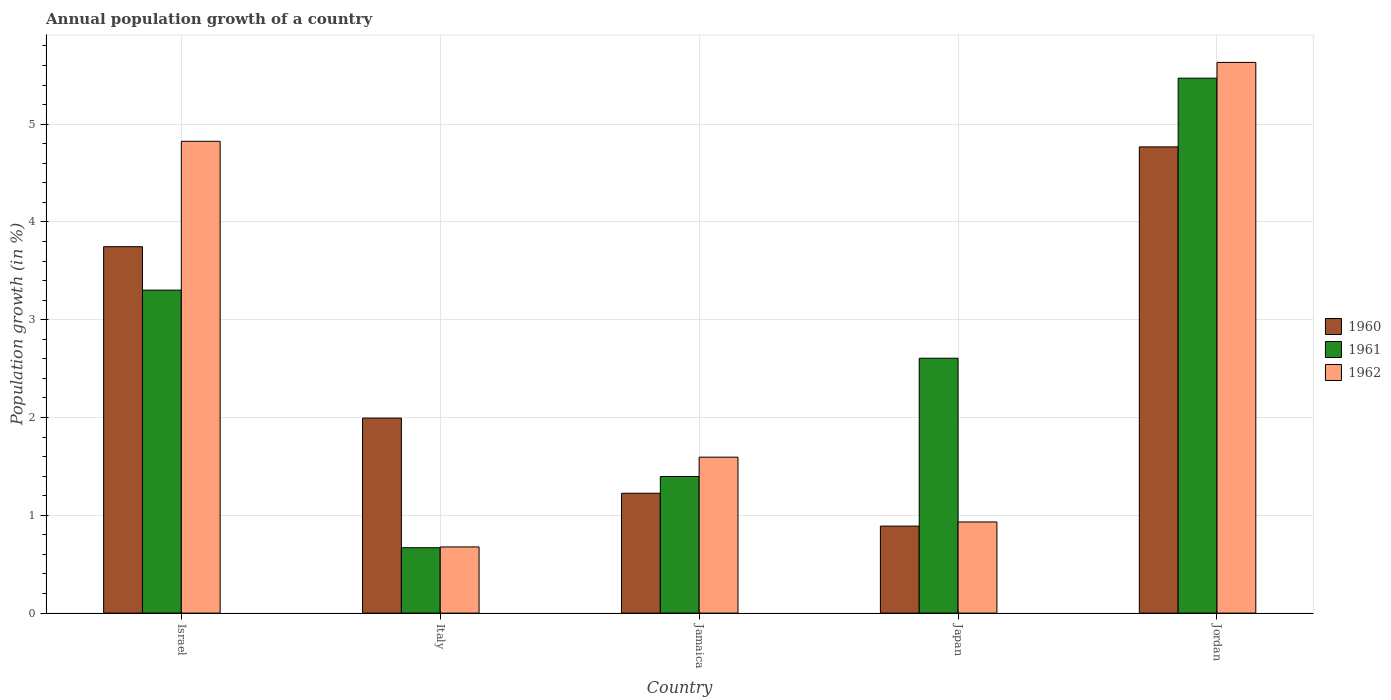How many different coloured bars are there?
Provide a short and direct response. 3. Are the number of bars on each tick of the X-axis equal?
Keep it short and to the point. Yes. How many bars are there on the 3rd tick from the right?
Offer a very short reply. 3. What is the label of the 1st group of bars from the left?
Provide a short and direct response. Israel. In how many cases, is the number of bars for a given country not equal to the number of legend labels?
Your answer should be very brief. 0. What is the annual population growth in 1961 in Jamaica?
Give a very brief answer. 1.4. Across all countries, what is the maximum annual population growth in 1962?
Ensure brevity in your answer.  5.63. Across all countries, what is the minimum annual population growth in 1960?
Provide a succinct answer. 0.89. In which country was the annual population growth in 1961 maximum?
Offer a very short reply. Jordan. What is the total annual population growth in 1961 in the graph?
Give a very brief answer. 13.44. What is the difference between the annual population growth in 1961 in Jamaica and that in Jordan?
Make the answer very short. -4.07. What is the difference between the annual population growth in 1961 in Italy and the annual population growth in 1960 in Japan?
Your answer should be compact. -0.22. What is the average annual population growth in 1961 per country?
Give a very brief answer. 2.69. What is the difference between the annual population growth of/in 1960 and annual population growth of/in 1961 in Italy?
Your response must be concise. 1.33. In how many countries, is the annual population growth in 1961 greater than 1.6 %?
Make the answer very short. 3. What is the ratio of the annual population growth in 1962 in Japan to that in Jordan?
Provide a succinct answer. 0.17. Is the annual population growth in 1960 in Italy less than that in Jordan?
Make the answer very short. Yes. What is the difference between the highest and the second highest annual population growth in 1961?
Offer a very short reply. -0.7. What is the difference between the highest and the lowest annual population growth in 1962?
Provide a short and direct response. 4.95. What does the 1st bar from the right in Israel represents?
Provide a succinct answer. 1962. Is it the case that in every country, the sum of the annual population growth in 1960 and annual population growth in 1961 is greater than the annual population growth in 1962?
Your answer should be compact. Yes. How many bars are there?
Your answer should be compact. 15. Are all the bars in the graph horizontal?
Make the answer very short. No. Are the values on the major ticks of Y-axis written in scientific E-notation?
Your answer should be very brief. No. Does the graph contain any zero values?
Offer a very short reply. No. Does the graph contain grids?
Your answer should be very brief. Yes. What is the title of the graph?
Offer a terse response. Annual population growth of a country. What is the label or title of the X-axis?
Keep it short and to the point. Country. What is the label or title of the Y-axis?
Your answer should be very brief. Population growth (in %). What is the Population growth (in %) of 1960 in Israel?
Offer a very short reply. 3.75. What is the Population growth (in %) of 1961 in Israel?
Provide a succinct answer. 3.3. What is the Population growth (in %) of 1962 in Israel?
Ensure brevity in your answer.  4.82. What is the Population growth (in %) in 1960 in Italy?
Your response must be concise. 1.99. What is the Population growth (in %) in 1961 in Italy?
Offer a terse response. 0.67. What is the Population growth (in %) in 1962 in Italy?
Your answer should be compact. 0.68. What is the Population growth (in %) of 1960 in Jamaica?
Provide a succinct answer. 1.23. What is the Population growth (in %) in 1961 in Jamaica?
Give a very brief answer. 1.4. What is the Population growth (in %) in 1962 in Jamaica?
Offer a very short reply. 1.59. What is the Population growth (in %) in 1960 in Japan?
Your answer should be compact. 0.89. What is the Population growth (in %) of 1961 in Japan?
Your answer should be very brief. 2.61. What is the Population growth (in %) in 1962 in Japan?
Provide a short and direct response. 0.93. What is the Population growth (in %) of 1960 in Jordan?
Keep it short and to the point. 4.77. What is the Population growth (in %) in 1961 in Jordan?
Your response must be concise. 5.47. What is the Population growth (in %) of 1962 in Jordan?
Your response must be concise. 5.63. Across all countries, what is the maximum Population growth (in %) of 1960?
Keep it short and to the point. 4.77. Across all countries, what is the maximum Population growth (in %) of 1961?
Ensure brevity in your answer.  5.47. Across all countries, what is the maximum Population growth (in %) in 1962?
Ensure brevity in your answer.  5.63. Across all countries, what is the minimum Population growth (in %) of 1960?
Provide a short and direct response. 0.89. Across all countries, what is the minimum Population growth (in %) of 1961?
Give a very brief answer. 0.67. Across all countries, what is the minimum Population growth (in %) of 1962?
Your answer should be very brief. 0.68. What is the total Population growth (in %) in 1960 in the graph?
Offer a very short reply. 12.62. What is the total Population growth (in %) of 1961 in the graph?
Provide a succinct answer. 13.44. What is the total Population growth (in %) of 1962 in the graph?
Ensure brevity in your answer.  13.66. What is the difference between the Population growth (in %) of 1960 in Israel and that in Italy?
Provide a short and direct response. 1.75. What is the difference between the Population growth (in %) of 1961 in Israel and that in Italy?
Offer a terse response. 2.63. What is the difference between the Population growth (in %) of 1962 in Israel and that in Italy?
Give a very brief answer. 4.15. What is the difference between the Population growth (in %) in 1960 in Israel and that in Jamaica?
Offer a terse response. 2.52. What is the difference between the Population growth (in %) of 1961 in Israel and that in Jamaica?
Offer a terse response. 1.91. What is the difference between the Population growth (in %) of 1962 in Israel and that in Jamaica?
Your answer should be compact. 3.23. What is the difference between the Population growth (in %) of 1960 in Israel and that in Japan?
Offer a terse response. 2.86. What is the difference between the Population growth (in %) of 1961 in Israel and that in Japan?
Offer a terse response. 0.7. What is the difference between the Population growth (in %) in 1962 in Israel and that in Japan?
Provide a succinct answer. 3.89. What is the difference between the Population growth (in %) of 1960 in Israel and that in Jordan?
Offer a very short reply. -1.02. What is the difference between the Population growth (in %) in 1961 in Israel and that in Jordan?
Provide a succinct answer. -2.17. What is the difference between the Population growth (in %) in 1962 in Israel and that in Jordan?
Your answer should be very brief. -0.81. What is the difference between the Population growth (in %) of 1960 in Italy and that in Jamaica?
Your response must be concise. 0.77. What is the difference between the Population growth (in %) of 1961 in Italy and that in Jamaica?
Give a very brief answer. -0.73. What is the difference between the Population growth (in %) in 1962 in Italy and that in Jamaica?
Provide a succinct answer. -0.92. What is the difference between the Population growth (in %) of 1960 in Italy and that in Japan?
Provide a short and direct response. 1.1. What is the difference between the Population growth (in %) in 1961 in Italy and that in Japan?
Give a very brief answer. -1.94. What is the difference between the Population growth (in %) in 1962 in Italy and that in Japan?
Your answer should be very brief. -0.26. What is the difference between the Population growth (in %) in 1960 in Italy and that in Jordan?
Ensure brevity in your answer.  -2.77. What is the difference between the Population growth (in %) of 1961 in Italy and that in Jordan?
Provide a succinct answer. -4.8. What is the difference between the Population growth (in %) in 1962 in Italy and that in Jordan?
Ensure brevity in your answer.  -4.95. What is the difference between the Population growth (in %) of 1960 in Jamaica and that in Japan?
Provide a short and direct response. 0.34. What is the difference between the Population growth (in %) in 1961 in Jamaica and that in Japan?
Offer a terse response. -1.21. What is the difference between the Population growth (in %) in 1962 in Jamaica and that in Japan?
Make the answer very short. 0.66. What is the difference between the Population growth (in %) in 1960 in Jamaica and that in Jordan?
Keep it short and to the point. -3.54. What is the difference between the Population growth (in %) in 1961 in Jamaica and that in Jordan?
Your response must be concise. -4.07. What is the difference between the Population growth (in %) of 1962 in Jamaica and that in Jordan?
Give a very brief answer. -4.04. What is the difference between the Population growth (in %) of 1960 in Japan and that in Jordan?
Provide a short and direct response. -3.88. What is the difference between the Population growth (in %) in 1961 in Japan and that in Jordan?
Give a very brief answer. -2.86. What is the difference between the Population growth (in %) in 1962 in Japan and that in Jordan?
Offer a terse response. -4.7. What is the difference between the Population growth (in %) in 1960 in Israel and the Population growth (in %) in 1961 in Italy?
Make the answer very short. 3.08. What is the difference between the Population growth (in %) in 1960 in Israel and the Population growth (in %) in 1962 in Italy?
Provide a short and direct response. 3.07. What is the difference between the Population growth (in %) of 1961 in Israel and the Population growth (in %) of 1962 in Italy?
Provide a succinct answer. 2.63. What is the difference between the Population growth (in %) in 1960 in Israel and the Population growth (in %) in 1961 in Jamaica?
Offer a very short reply. 2.35. What is the difference between the Population growth (in %) of 1960 in Israel and the Population growth (in %) of 1962 in Jamaica?
Ensure brevity in your answer.  2.15. What is the difference between the Population growth (in %) of 1961 in Israel and the Population growth (in %) of 1962 in Jamaica?
Keep it short and to the point. 1.71. What is the difference between the Population growth (in %) in 1960 in Israel and the Population growth (in %) in 1961 in Japan?
Offer a terse response. 1.14. What is the difference between the Population growth (in %) of 1960 in Israel and the Population growth (in %) of 1962 in Japan?
Your answer should be compact. 2.81. What is the difference between the Population growth (in %) in 1961 in Israel and the Population growth (in %) in 1962 in Japan?
Your answer should be compact. 2.37. What is the difference between the Population growth (in %) of 1960 in Israel and the Population growth (in %) of 1961 in Jordan?
Make the answer very short. -1.72. What is the difference between the Population growth (in %) of 1960 in Israel and the Population growth (in %) of 1962 in Jordan?
Provide a short and direct response. -1.88. What is the difference between the Population growth (in %) of 1961 in Israel and the Population growth (in %) of 1962 in Jordan?
Your answer should be compact. -2.33. What is the difference between the Population growth (in %) of 1960 in Italy and the Population growth (in %) of 1961 in Jamaica?
Offer a terse response. 0.6. What is the difference between the Population growth (in %) of 1960 in Italy and the Population growth (in %) of 1962 in Jamaica?
Provide a short and direct response. 0.4. What is the difference between the Population growth (in %) of 1961 in Italy and the Population growth (in %) of 1962 in Jamaica?
Your answer should be compact. -0.93. What is the difference between the Population growth (in %) in 1960 in Italy and the Population growth (in %) in 1961 in Japan?
Offer a terse response. -0.61. What is the difference between the Population growth (in %) of 1960 in Italy and the Population growth (in %) of 1962 in Japan?
Make the answer very short. 1.06. What is the difference between the Population growth (in %) of 1961 in Italy and the Population growth (in %) of 1962 in Japan?
Offer a very short reply. -0.26. What is the difference between the Population growth (in %) in 1960 in Italy and the Population growth (in %) in 1961 in Jordan?
Your answer should be compact. -3.48. What is the difference between the Population growth (in %) in 1960 in Italy and the Population growth (in %) in 1962 in Jordan?
Provide a short and direct response. -3.64. What is the difference between the Population growth (in %) in 1961 in Italy and the Population growth (in %) in 1962 in Jordan?
Make the answer very short. -4.96. What is the difference between the Population growth (in %) of 1960 in Jamaica and the Population growth (in %) of 1961 in Japan?
Offer a terse response. -1.38. What is the difference between the Population growth (in %) in 1960 in Jamaica and the Population growth (in %) in 1962 in Japan?
Your answer should be very brief. 0.29. What is the difference between the Population growth (in %) of 1961 in Jamaica and the Population growth (in %) of 1962 in Japan?
Provide a short and direct response. 0.46. What is the difference between the Population growth (in %) of 1960 in Jamaica and the Population growth (in %) of 1961 in Jordan?
Your response must be concise. -4.24. What is the difference between the Population growth (in %) of 1960 in Jamaica and the Population growth (in %) of 1962 in Jordan?
Provide a short and direct response. -4.41. What is the difference between the Population growth (in %) in 1961 in Jamaica and the Population growth (in %) in 1962 in Jordan?
Ensure brevity in your answer.  -4.23. What is the difference between the Population growth (in %) in 1960 in Japan and the Population growth (in %) in 1961 in Jordan?
Make the answer very short. -4.58. What is the difference between the Population growth (in %) in 1960 in Japan and the Population growth (in %) in 1962 in Jordan?
Your response must be concise. -4.74. What is the difference between the Population growth (in %) in 1961 in Japan and the Population growth (in %) in 1962 in Jordan?
Provide a succinct answer. -3.02. What is the average Population growth (in %) in 1960 per country?
Ensure brevity in your answer.  2.52. What is the average Population growth (in %) in 1961 per country?
Give a very brief answer. 2.69. What is the average Population growth (in %) of 1962 per country?
Your answer should be compact. 2.73. What is the difference between the Population growth (in %) of 1960 and Population growth (in %) of 1961 in Israel?
Offer a terse response. 0.44. What is the difference between the Population growth (in %) in 1960 and Population growth (in %) in 1962 in Israel?
Your answer should be very brief. -1.08. What is the difference between the Population growth (in %) in 1961 and Population growth (in %) in 1962 in Israel?
Offer a very short reply. -1.52. What is the difference between the Population growth (in %) of 1960 and Population growth (in %) of 1961 in Italy?
Ensure brevity in your answer.  1.33. What is the difference between the Population growth (in %) of 1960 and Population growth (in %) of 1962 in Italy?
Your response must be concise. 1.32. What is the difference between the Population growth (in %) of 1961 and Population growth (in %) of 1962 in Italy?
Keep it short and to the point. -0.01. What is the difference between the Population growth (in %) in 1960 and Population growth (in %) in 1961 in Jamaica?
Offer a terse response. -0.17. What is the difference between the Population growth (in %) of 1960 and Population growth (in %) of 1962 in Jamaica?
Provide a short and direct response. -0.37. What is the difference between the Population growth (in %) in 1961 and Population growth (in %) in 1962 in Jamaica?
Your answer should be very brief. -0.2. What is the difference between the Population growth (in %) of 1960 and Population growth (in %) of 1961 in Japan?
Your answer should be very brief. -1.72. What is the difference between the Population growth (in %) of 1960 and Population growth (in %) of 1962 in Japan?
Ensure brevity in your answer.  -0.04. What is the difference between the Population growth (in %) of 1961 and Population growth (in %) of 1962 in Japan?
Make the answer very short. 1.67. What is the difference between the Population growth (in %) in 1960 and Population growth (in %) in 1961 in Jordan?
Provide a succinct answer. -0.7. What is the difference between the Population growth (in %) of 1960 and Population growth (in %) of 1962 in Jordan?
Offer a very short reply. -0.86. What is the difference between the Population growth (in %) in 1961 and Population growth (in %) in 1962 in Jordan?
Your answer should be compact. -0.16. What is the ratio of the Population growth (in %) in 1960 in Israel to that in Italy?
Keep it short and to the point. 1.88. What is the ratio of the Population growth (in %) of 1961 in Israel to that in Italy?
Give a very brief answer. 4.94. What is the ratio of the Population growth (in %) in 1962 in Israel to that in Italy?
Your answer should be compact. 7.13. What is the ratio of the Population growth (in %) in 1960 in Israel to that in Jamaica?
Ensure brevity in your answer.  3.06. What is the ratio of the Population growth (in %) in 1961 in Israel to that in Jamaica?
Keep it short and to the point. 2.36. What is the ratio of the Population growth (in %) of 1962 in Israel to that in Jamaica?
Offer a terse response. 3.03. What is the ratio of the Population growth (in %) of 1960 in Israel to that in Japan?
Keep it short and to the point. 4.21. What is the ratio of the Population growth (in %) in 1961 in Israel to that in Japan?
Offer a terse response. 1.27. What is the ratio of the Population growth (in %) in 1962 in Israel to that in Japan?
Provide a succinct answer. 5.18. What is the ratio of the Population growth (in %) in 1960 in Israel to that in Jordan?
Your response must be concise. 0.79. What is the ratio of the Population growth (in %) in 1961 in Israel to that in Jordan?
Offer a terse response. 0.6. What is the ratio of the Population growth (in %) in 1962 in Israel to that in Jordan?
Provide a short and direct response. 0.86. What is the ratio of the Population growth (in %) of 1960 in Italy to that in Jamaica?
Keep it short and to the point. 1.63. What is the ratio of the Population growth (in %) of 1961 in Italy to that in Jamaica?
Give a very brief answer. 0.48. What is the ratio of the Population growth (in %) in 1962 in Italy to that in Jamaica?
Ensure brevity in your answer.  0.42. What is the ratio of the Population growth (in %) in 1960 in Italy to that in Japan?
Offer a terse response. 2.24. What is the ratio of the Population growth (in %) in 1961 in Italy to that in Japan?
Your answer should be compact. 0.26. What is the ratio of the Population growth (in %) of 1962 in Italy to that in Japan?
Make the answer very short. 0.73. What is the ratio of the Population growth (in %) in 1960 in Italy to that in Jordan?
Give a very brief answer. 0.42. What is the ratio of the Population growth (in %) in 1961 in Italy to that in Jordan?
Keep it short and to the point. 0.12. What is the ratio of the Population growth (in %) in 1962 in Italy to that in Jordan?
Keep it short and to the point. 0.12. What is the ratio of the Population growth (in %) in 1960 in Jamaica to that in Japan?
Your answer should be compact. 1.38. What is the ratio of the Population growth (in %) in 1961 in Jamaica to that in Japan?
Make the answer very short. 0.54. What is the ratio of the Population growth (in %) in 1962 in Jamaica to that in Japan?
Give a very brief answer. 1.71. What is the ratio of the Population growth (in %) in 1960 in Jamaica to that in Jordan?
Provide a short and direct response. 0.26. What is the ratio of the Population growth (in %) of 1961 in Jamaica to that in Jordan?
Provide a succinct answer. 0.26. What is the ratio of the Population growth (in %) of 1962 in Jamaica to that in Jordan?
Your answer should be very brief. 0.28. What is the ratio of the Population growth (in %) of 1960 in Japan to that in Jordan?
Offer a very short reply. 0.19. What is the ratio of the Population growth (in %) of 1961 in Japan to that in Jordan?
Provide a succinct answer. 0.48. What is the ratio of the Population growth (in %) in 1962 in Japan to that in Jordan?
Ensure brevity in your answer.  0.17. What is the difference between the highest and the second highest Population growth (in %) of 1960?
Ensure brevity in your answer.  1.02. What is the difference between the highest and the second highest Population growth (in %) of 1961?
Ensure brevity in your answer.  2.17. What is the difference between the highest and the second highest Population growth (in %) of 1962?
Your response must be concise. 0.81. What is the difference between the highest and the lowest Population growth (in %) in 1960?
Your answer should be very brief. 3.88. What is the difference between the highest and the lowest Population growth (in %) in 1961?
Offer a very short reply. 4.8. What is the difference between the highest and the lowest Population growth (in %) in 1962?
Your response must be concise. 4.95. 